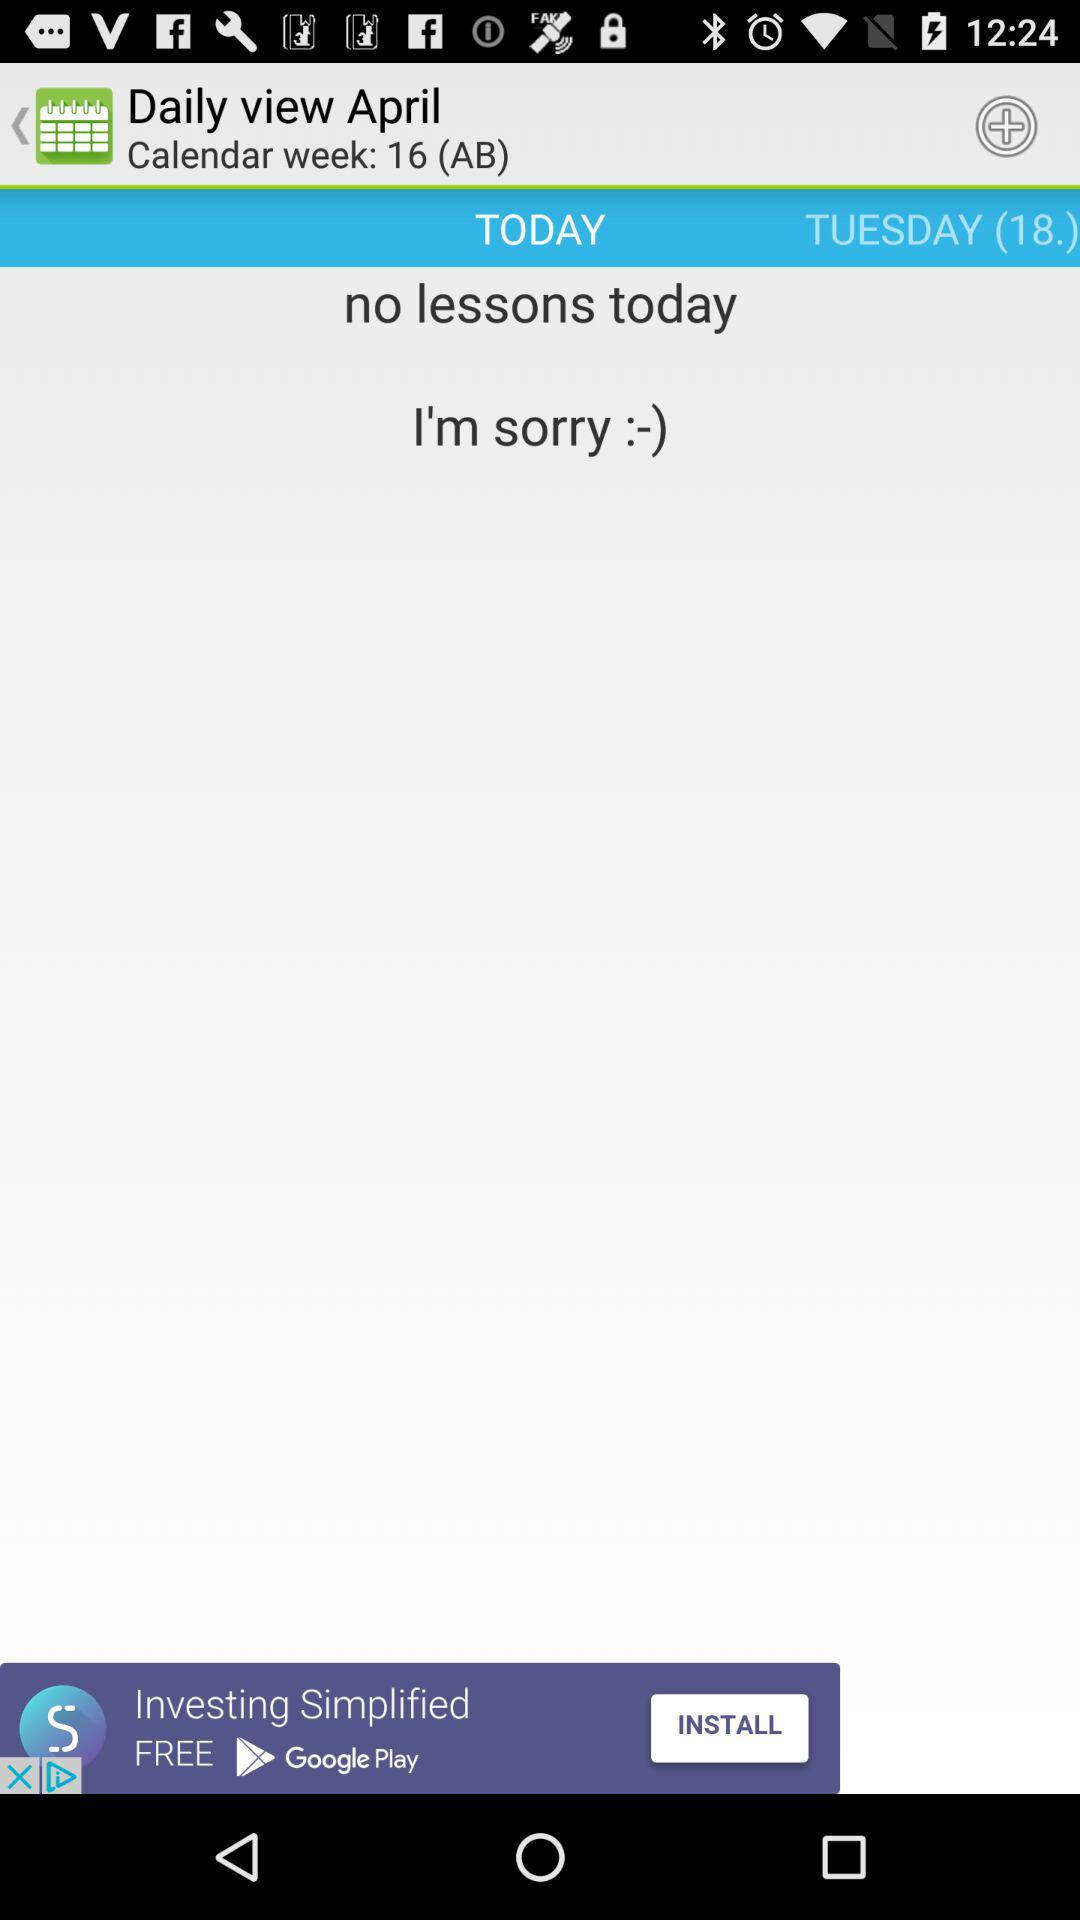What calendar week is going on currently? The current calendar week is 16 (AB). 